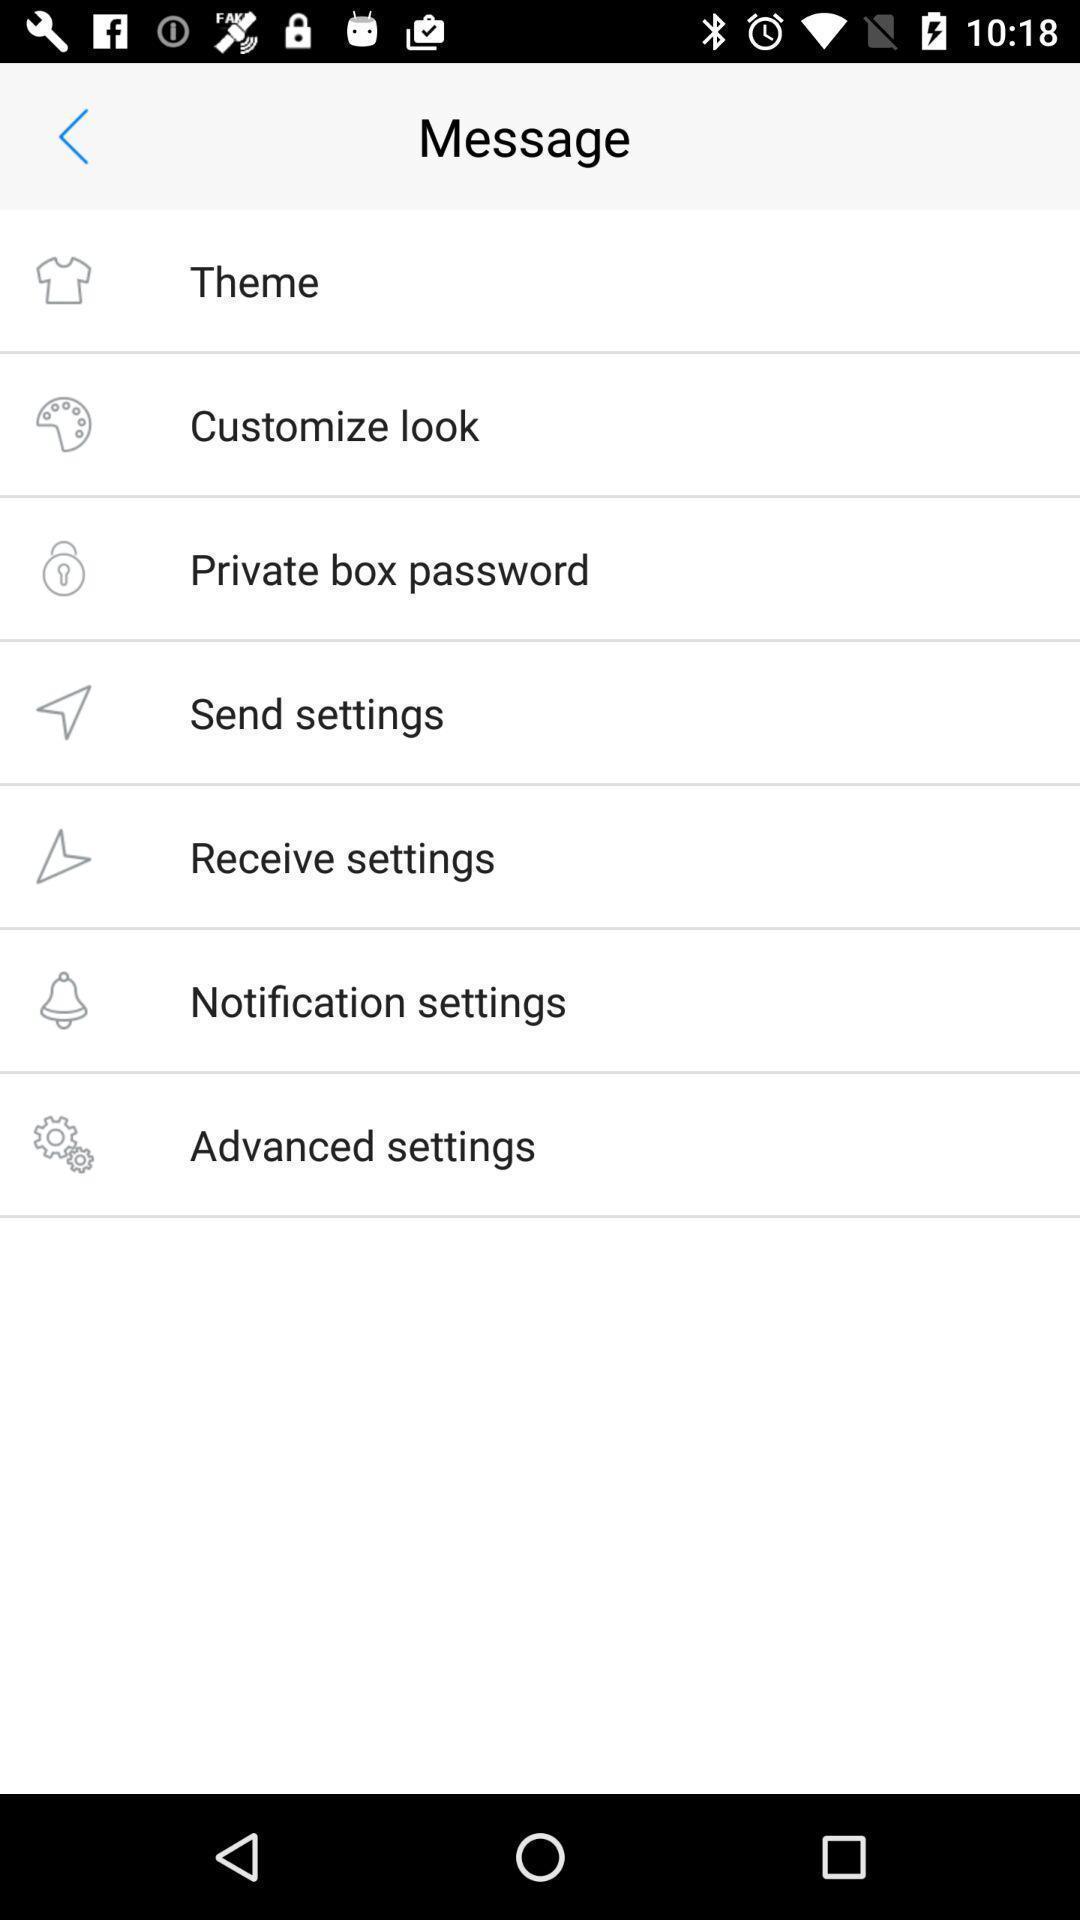Describe the visual elements of this screenshot. Page showing options in message. 